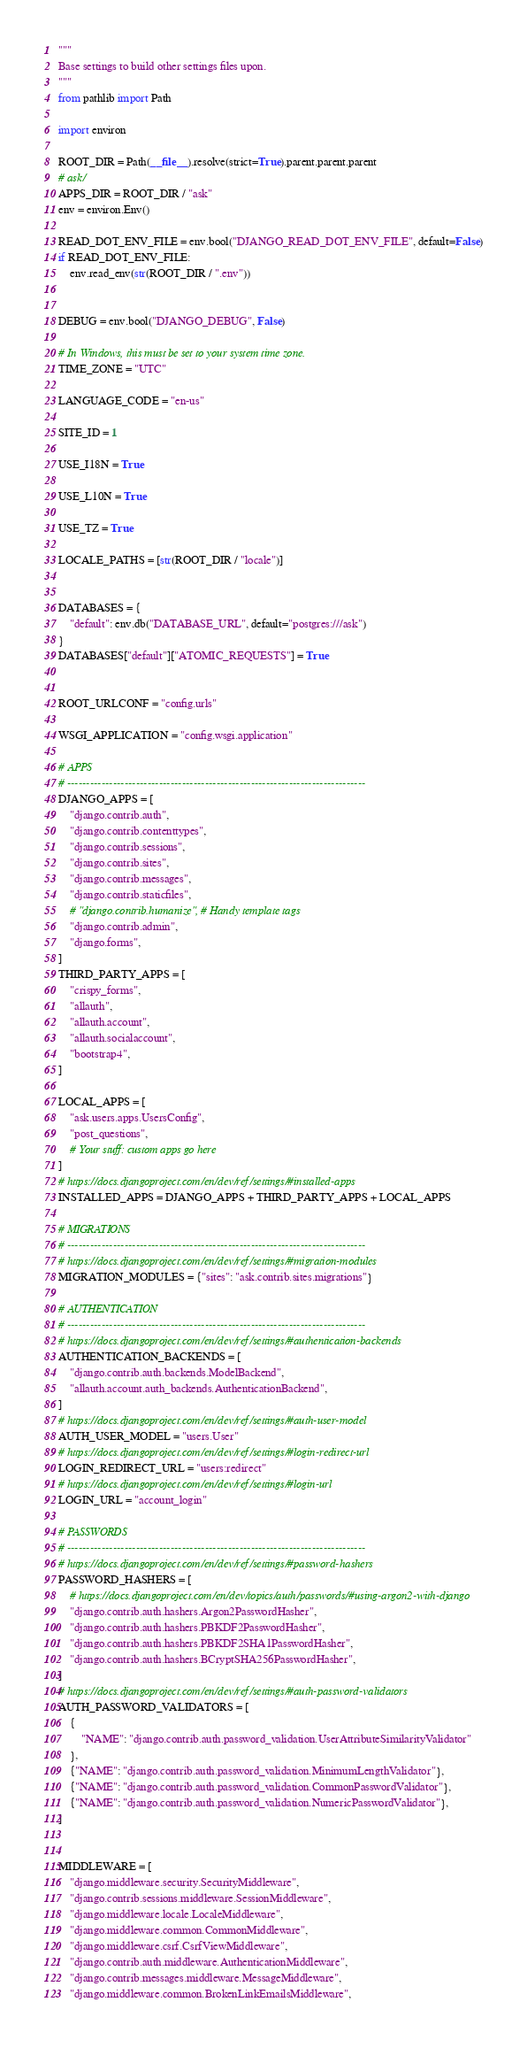Convert code to text. <code><loc_0><loc_0><loc_500><loc_500><_Python_>"""
Base settings to build other settings files upon.
"""
from pathlib import Path

import environ

ROOT_DIR = Path(__file__).resolve(strict=True).parent.parent.parent
# ask/
APPS_DIR = ROOT_DIR / "ask"
env = environ.Env()

READ_DOT_ENV_FILE = env.bool("DJANGO_READ_DOT_ENV_FILE", default=False)
if READ_DOT_ENV_FILE:
    env.read_env(str(ROOT_DIR / ".env"))


DEBUG = env.bool("DJANGO_DEBUG", False)

# In Windows, this must be set to your system time zone.
TIME_ZONE = "UTC"

LANGUAGE_CODE = "en-us"

SITE_ID = 1

USE_I18N = True

USE_L10N = True

USE_TZ = True

LOCALE_PATHS = [str(ROOT_DIR / "locale")]


DATABASES = {
    "default": env.db("DATABASE_URL", default="postgres:///ask")
}
DATABASES["default"]["ATOMIC_REQUESTS"] = True


ROOT_URLCONF = "config.urls"

WSGI_APPLICATION = "config.wsgi.application"

# APPS
# ------------------------------------------------------------------------------
DJANGO_APPS = [
    "django.contrib.auth",
    "django.contrib.contenttypes",
    "django.contrib.sessions",
    "django.contrib.sites",
    "django.contrib.messages",
    "django.contrib.staticfiles",
    # "django.contrib.humanize", # Handy template tags
    "django.contrib.admin",
    "django.forms",
]
THIRD_PARTY_APPS = [
    "crispy_forms",
    "allauth",
    "allauth.account",
    "allauth.socialaccount",
    "bootstrap4",
]

LOCAL_APPS = [
    "ask.users.apps.UsersConfig",
    "post_questions",
    # Your stuff: custom apps go here
]
# https://docs.djangoproject.com/en/dev/ref/settings/#installed-apps
INSTALLED_APPS = DJANGO_APPS + THIRD_PARTY_APPS + LOCAL_APPS

# MIGRATIONS
# ------------------------------------------------------------------------------
# https://docs.djangoproject.com/en/dev/ref/settings/#migration-modules
MIGRATION_MODULES = {"sites": "ask.contrib.sites.migrations"}

# AUTHENTICATION
# ------------------------------------------------------------------------------
# https://docs.djangoproject.com/en/dev/ref/settings/#authentication-backends
AUTHENTICATION_BACKENDS = [
    "django.contrib.auth.backends.ModelBackend",
    "allauth.account.auth_backends.AuthenticationBackend",
]
# https://docs.djangoproject.com/en/dev/ref/settings/#auth-user-model
AUTH_USER_MODEL = "users.User"
# https://docs.djangoproject.com/en/dev/ref/settings/#login-redirect-url
LOGIN_REDIRECT_URL = "users:redirect"
# https://docs.djangoproject.com/en/dev/ref/settings/#login-url
LOGIN_URL = "account_login"

# PASSWORDS
# ------------------------------------------------------------------------------
# https://docs.djangoproject.com/en/dev/ref/settings/#password-hashers
PASSWORD_HASHERS = [
    # https://docs.djangoproject.com/en/dev/topics/auth/passwords/#using-argon2-with-django
    "django.contrib.auth.hashers.Argon2PasswordHasher",
    "django.contrib.auth.hashers.PBKDF2PasswordHasher",
    "django.contrib.auth.hashers.PBKDF2SHA1PasswordHasher",
    "django.contrib.auth.hashers.BCryptSHA256PasswordHasher",
]
# https://docs.djangoproject.com/en/dev/ref/settings/#auth-password-validators
AUTH_PASSWORD_VALIDATORS = [
    {
        "NAME": "django.contrib.auth.password_validation.UserAttributeSimilarityValidator"
    },
    {"NAME": "django.contrib.auth.password_validation.MinimumLengthValidator"},
    {"NAME": "django.contrib.auth.password_validation.CommonPasswordValidator"},
    {"NAME": "django.contrib.auth.password_validation.NumericPasswordValidator"},
]


MIDDLEWARE = [
    "django.middleware.security.SecurityMiddleware",
    "django.contrib.sessions.middleware.SessionMiddleware",
    "django.middleware.locale.LocaleMiddleware",
    "django.middleware.common.CommonMiddleware",
    "django.middleware.csrf.CsrfViewMiddleware",
    "django.contrib.auth.middleware.AuthenticationMiddleware",
    "django.contrib.messages.middleware.MessageMiddleware",
    "django.middleware.common.BrokenLinkEmailsMiddleware",</code> 